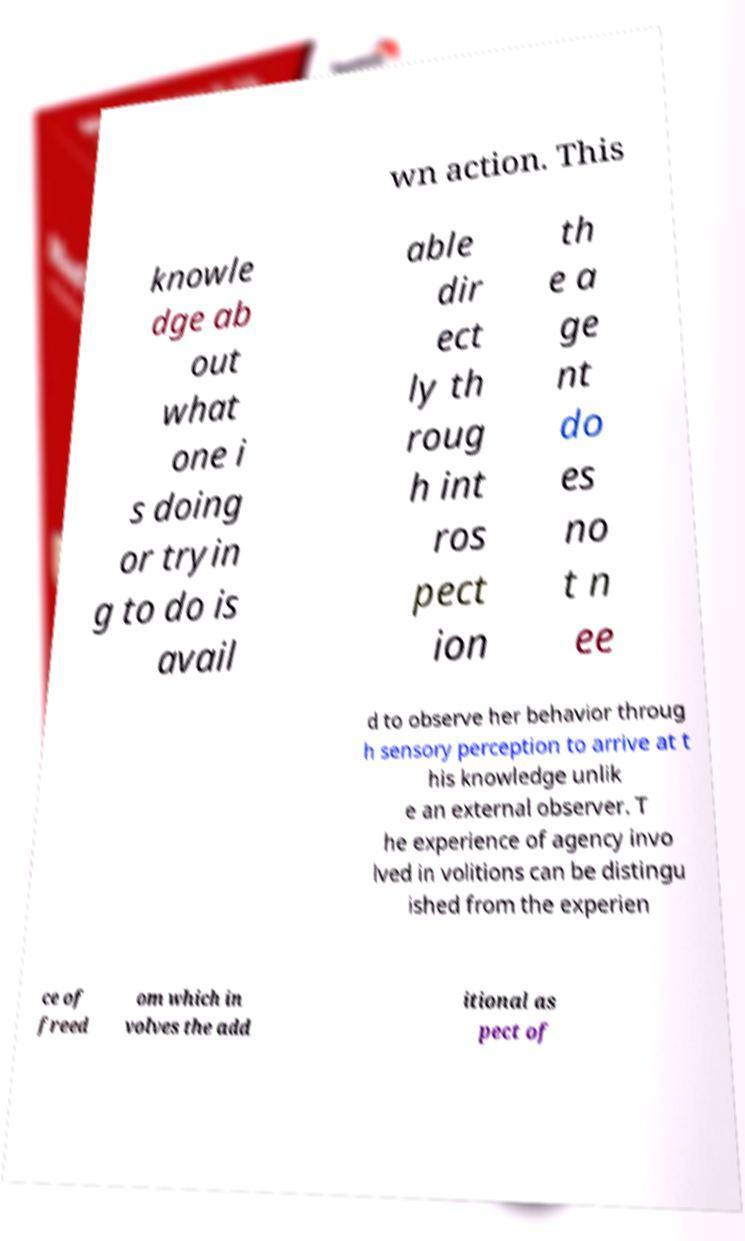I need the written content from this picture converted into text. Can you do that? wn action. This knowle dge ab out what one i s doing or tryin g to do is avail able dir ect ly th roug h int ros pect ion th e a ge nt do es no t n ee d to observe her behavior throug h sensory perception to arrive at t his knowledge unlik e an external observer. T he experience of agency invo lved in volitions can be distingu ished from the experien ce of freed om which in volves the add itional as pect of 